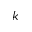Convert formula to latex. <formula><loc_0><loc_0><loc_500><loc_500>k</formula> 